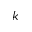Convert formula to latex. <formula><loc_0><loc_0><loc_500><loc_500>k</formula> 